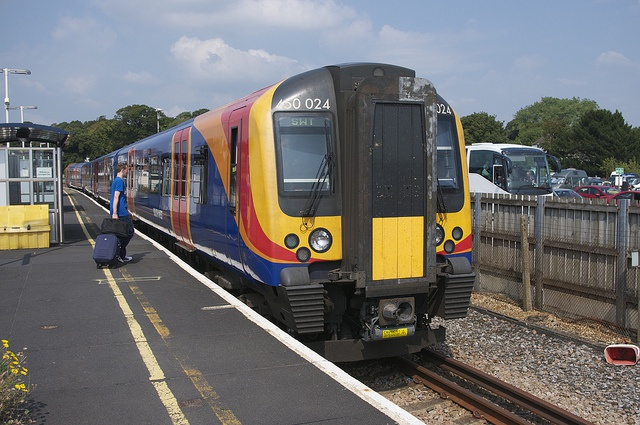Describe the objects in this image and their specific colors. I can see train in gray, black, navy, and orange tones, bus in gray, blue, lightgray, and black tones, people in gray, black, blue, and navy tones, suitcase in gray, darkblue, black, and navy tones, and car in gray, blue, and darkgray tones in this image. 